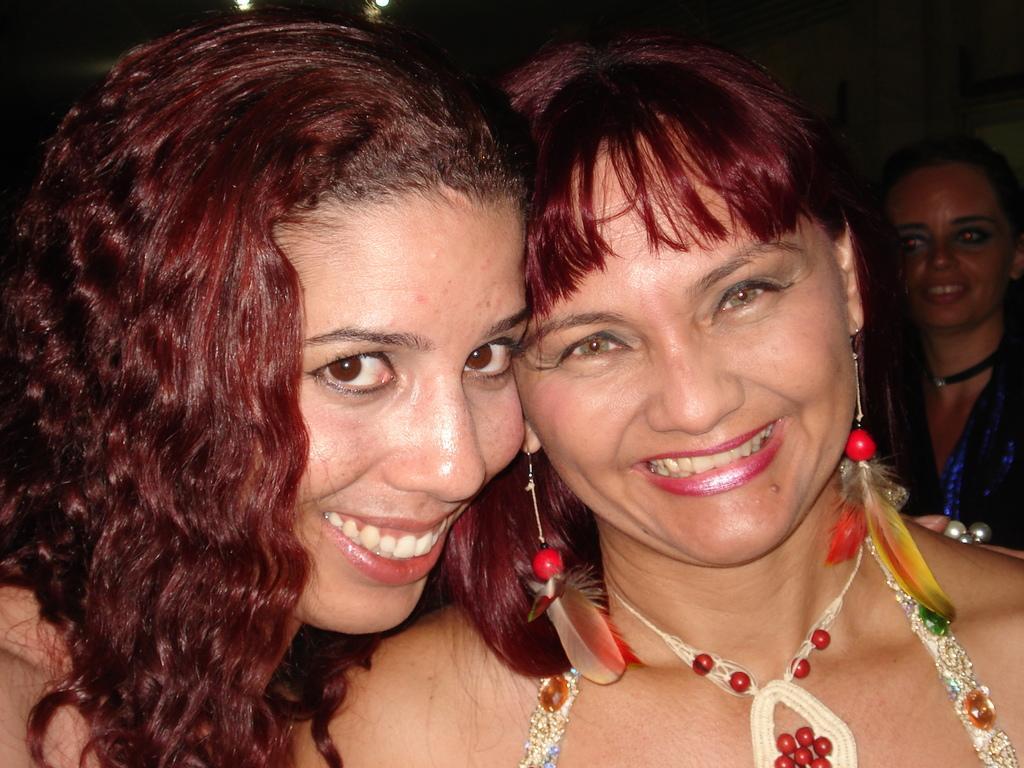How would you summarize this image in a sentence or two? In this image, I can see two women smiling. This woman wore earrings and a necklace. In the background, I can see another woman smiling. 